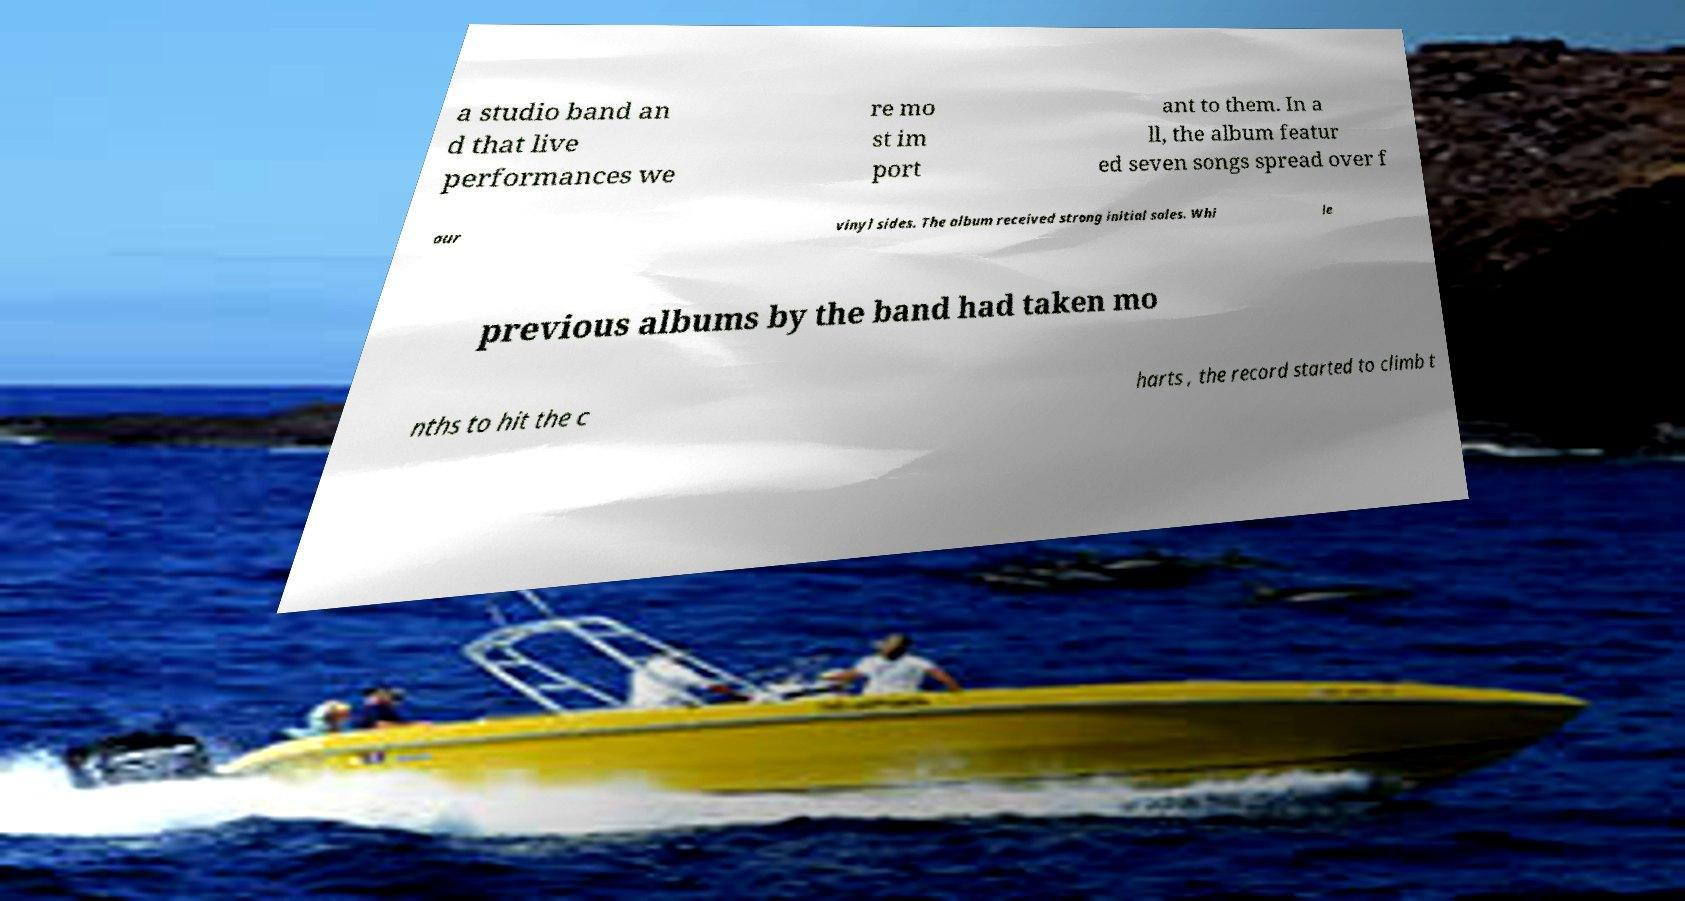Could you assist in decoding the text presented in this image and type it out clearly? a studio band an d that live performances we re mo st im port ant to them. In a ll, the album featur ed seven songs spread over f our vinyl sides. The album received strong initial sales. Whi le previous albums by the band had taken mo nths to hit the c harts , the record started to climb t 